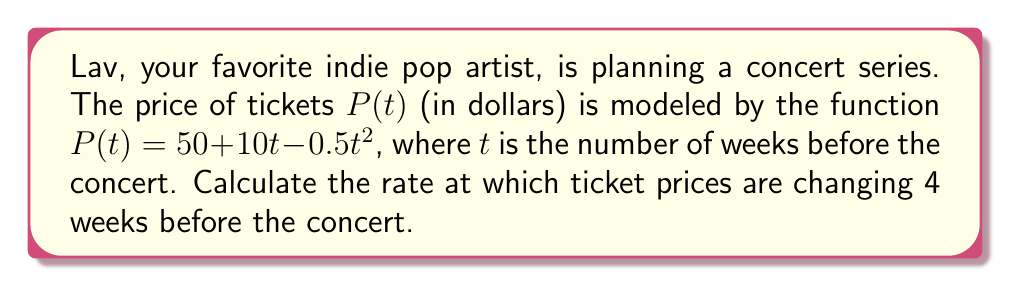Teach me how to tackle this problem. To find the rate of change in ticket prices, we need to calculate the derivative of the price function $P(t)$ and then evaluate it at $t = 4$.

Step 1: Find the derivative of $P(t)$.
$$\begin{align}
P(t) &= 50 + 10t - 0.5t^2 \\
P'(t) &= 10 - t
\end{align}$$

Step 2: Evaluate $P'(t)$ at $t = 4$.
$$\begin{align}
P'(4) &= 10 - 4 \\
&= 6
\end{align}$$

The rate of change is positive, indicating that ticket prices are increasing 4 weeks before the concert. Specifically, they are increasing at a rate of $6 per week.
Answer: $6 per week 